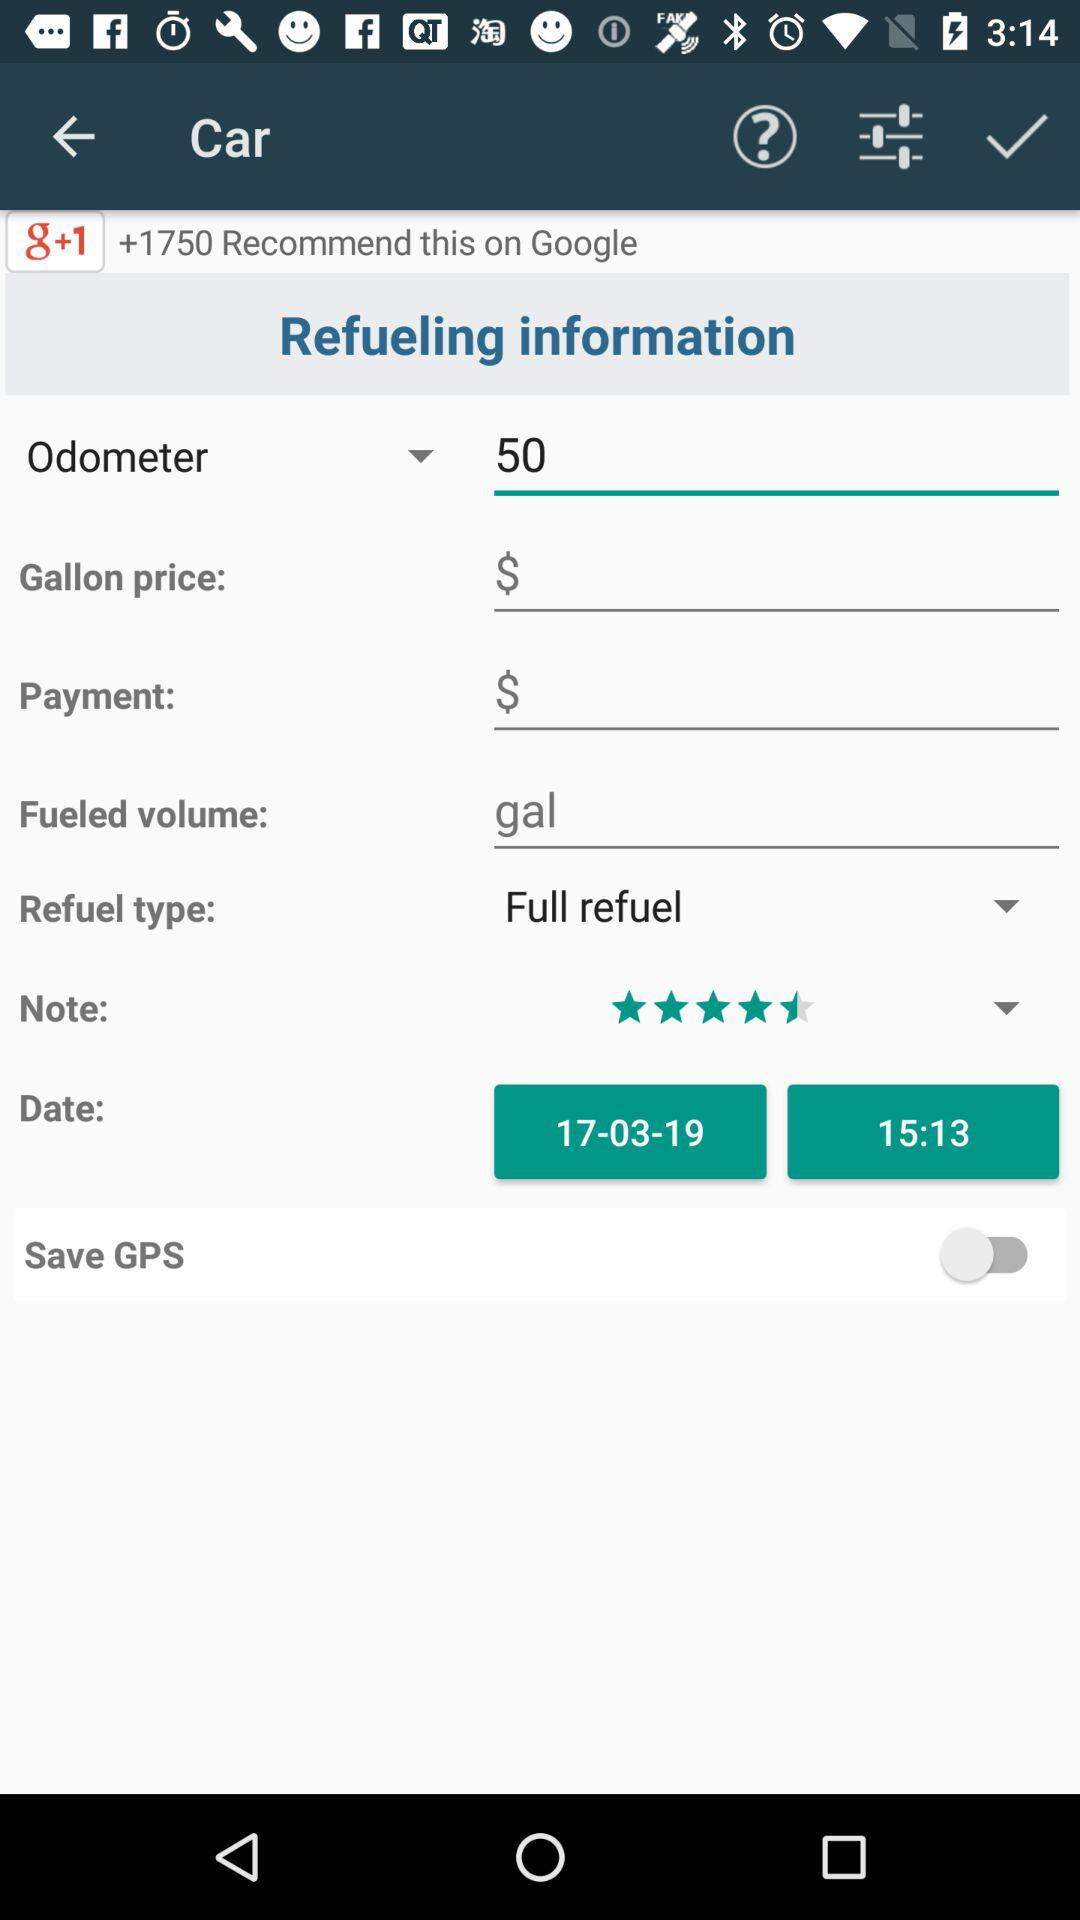What is the rating? The rating is 4.5 stars. 